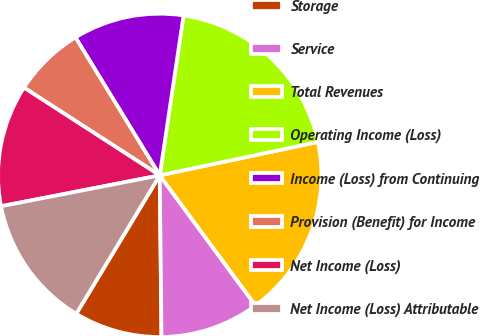<chart> <loc_0><loc_0><loc_500><loc_500><pie_chart><fcel>Storage<fcel>Service<fcel>Total Revenues<fcel>Operating Income (Loss)<fcel>Income (Loss) from Continuing<fcel>Provision (Benefit) for Income<fcel>Net Income (Loss)<fcel>Net Income (Loss) Attributable<nl><fcel>8.81%<fcel>9.92%<fcel>18.22%<fcel>19.33%<fcel>11.08%<fcel>7.14%<fcel>12.19%<fcel>13.3%<nl></chart> 